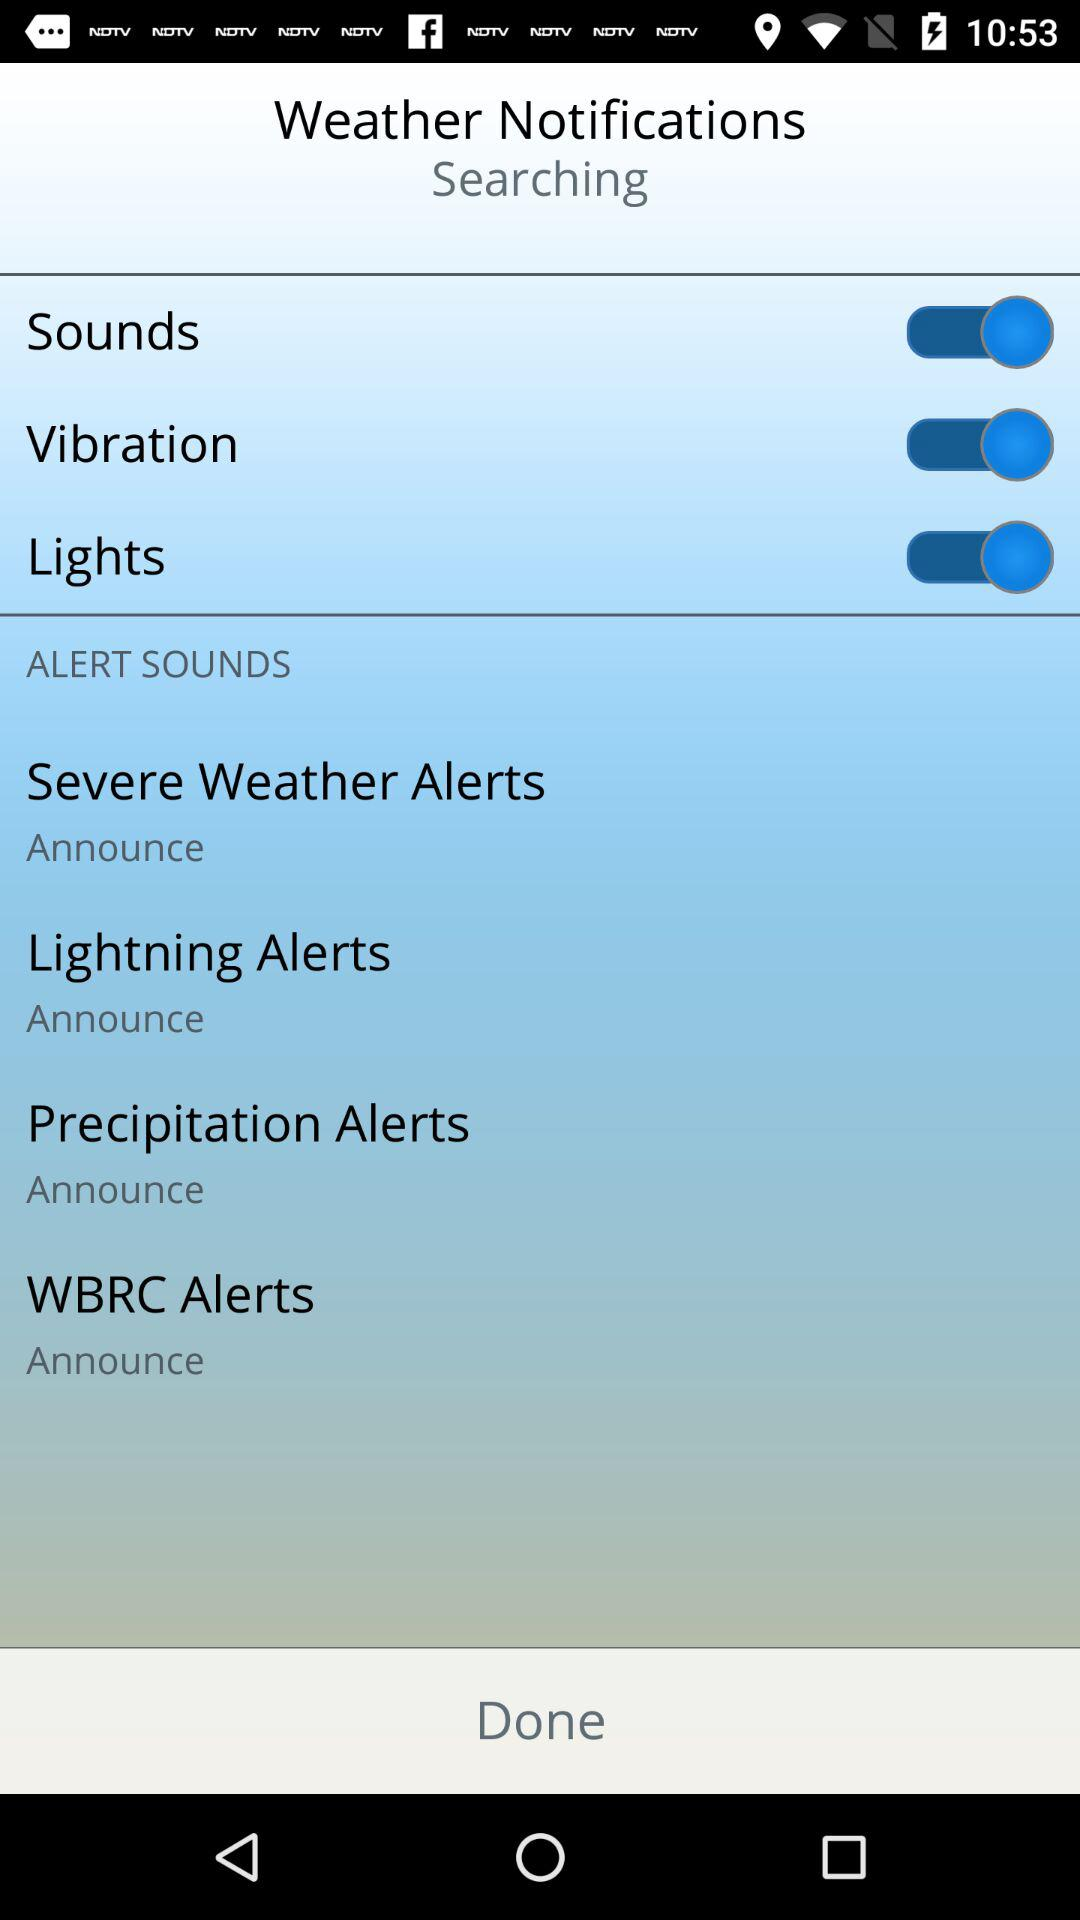What is the timing showing on display?
When the provided information is insufficient, respond with <no answer>. <no answer> 